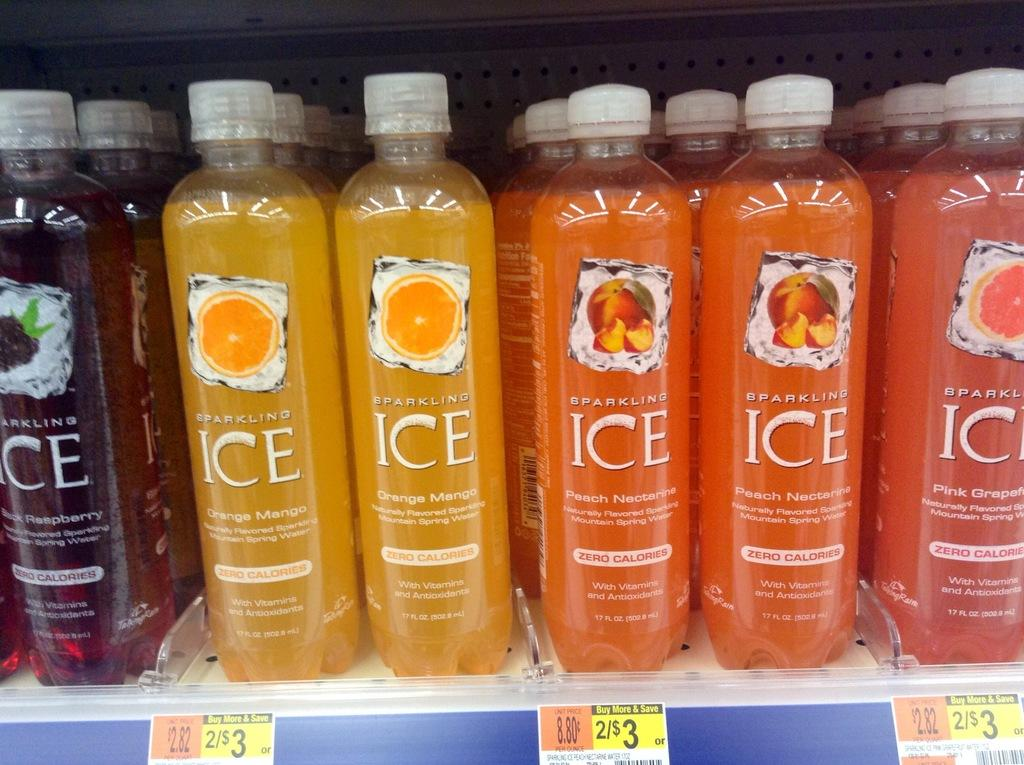What type of beverage containers are visible in the image? There are juice bottles in the image. What colors can be seen among the juice bottles? Some of the juice bottles are yellow in color, and some are orange in color. How can the price of the juice bottles be determined? Price tags are present at the bottom of the bottles. Is there a garden visible in the image? No, there is no garden present in the image. What type of metal is used to make the juice bottles? The juice bottles are not made of metal; they are made of glass or plastic. 